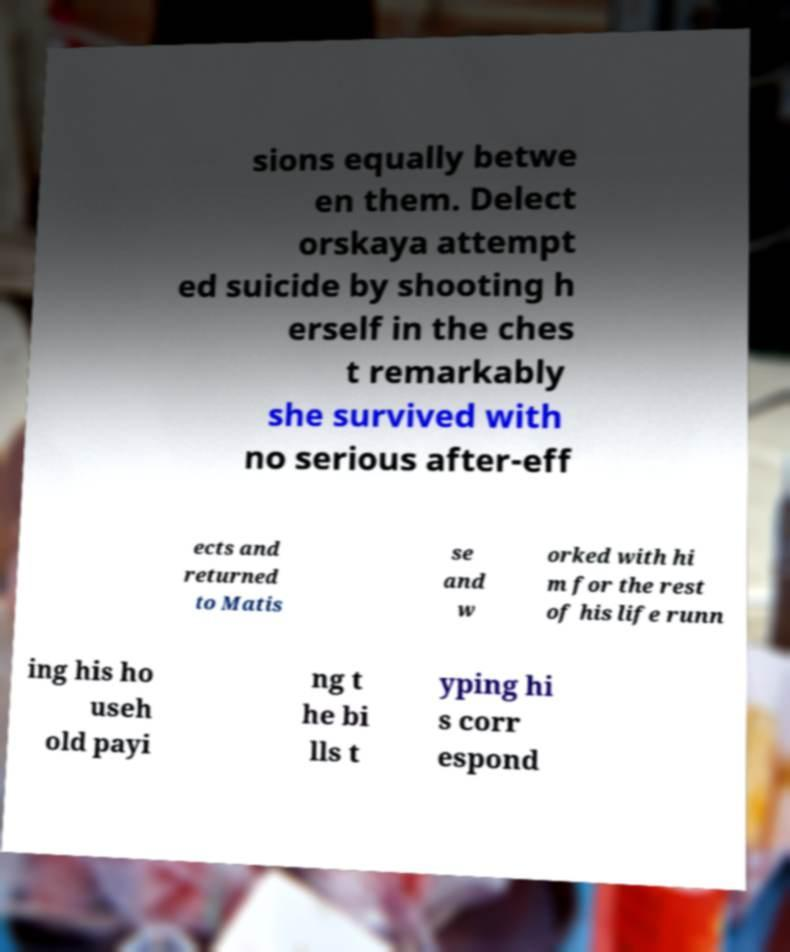Can you read and provide the text displayed in the image?This photo seems to have some interesting text. Can you extract and type it out for me? sions equally betwe en them. Delect orskaya attempt ed suicide by shooting h erself in the ches t remarkably she survived with no serious after-eff ects and returned to Matis se and w orked with hi m for the rest of his life runn ing his ho useh old payi ng t he bi lls t yping hi s corr espond 